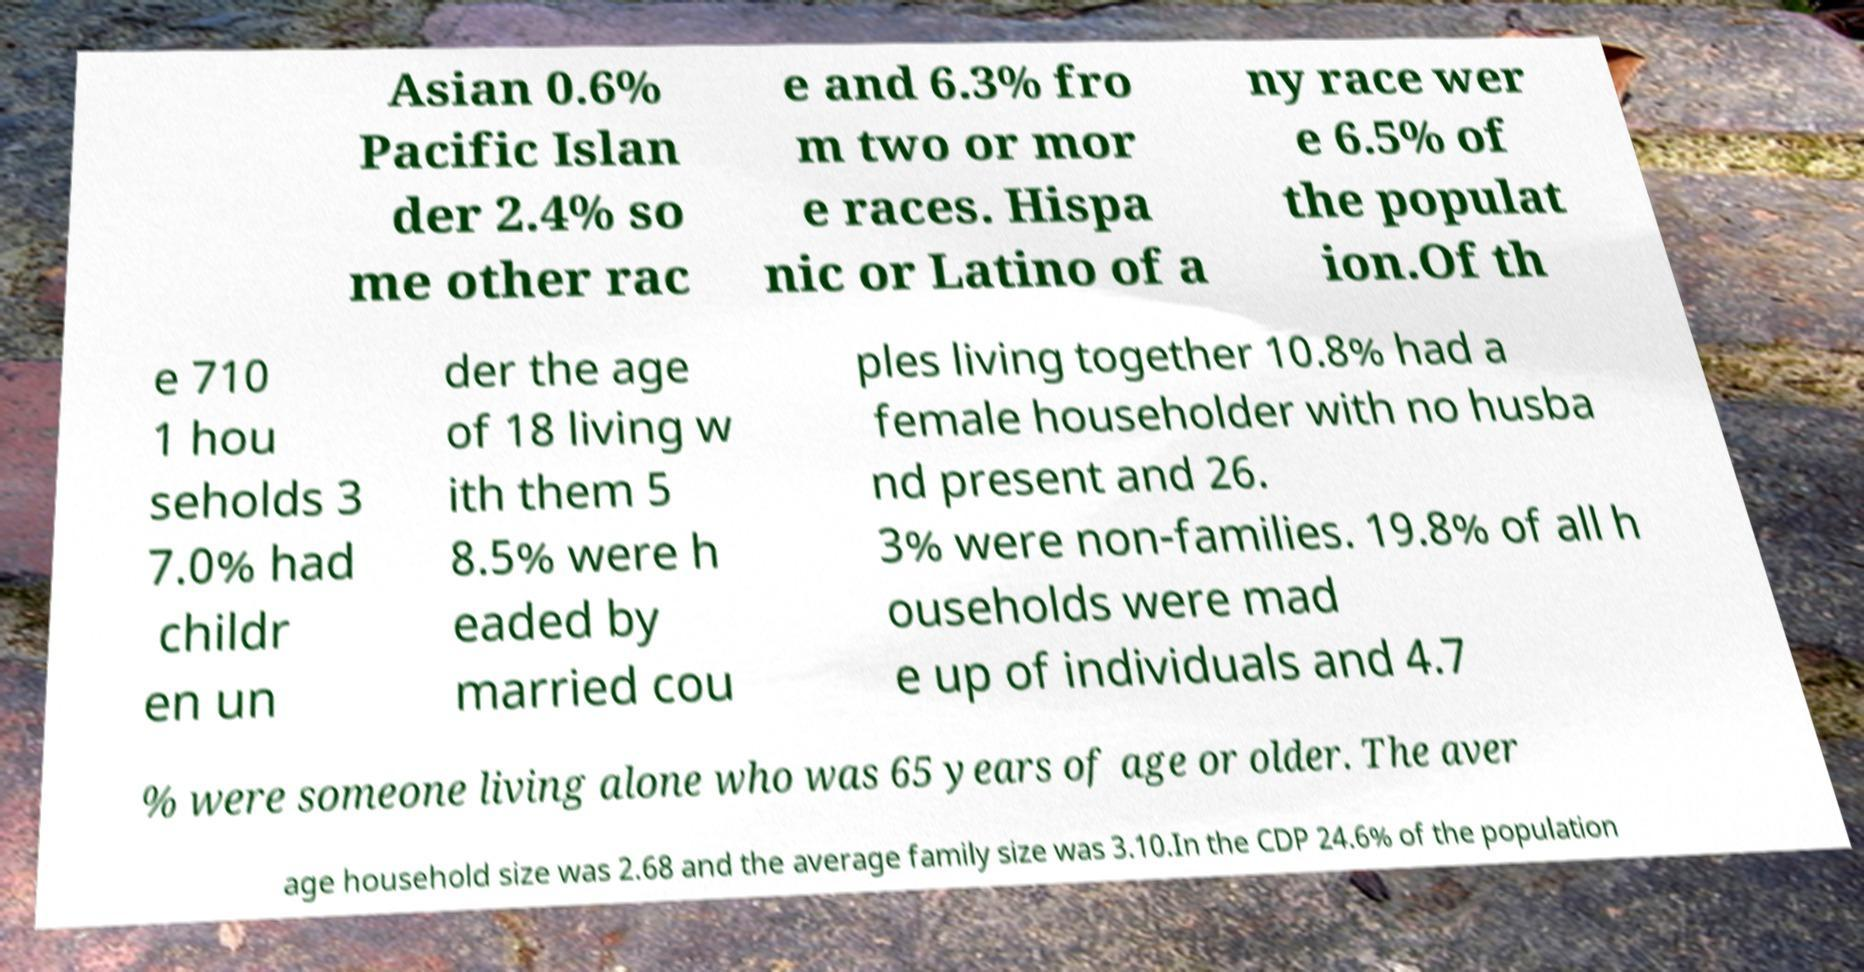Could you extract and type out the text from this image? Asian 0.6% Pacific Islan der 2.4% so me other rac e and 6.3% fro m two or mor e races. Hispa nic or Latino of a ny race wer e 6.5% of the populat ion.Of th e 710 1 hou seholds 3 7.0% had childr en un der the age of 18 living w ith them 5 8.5% were h eaded by married cou ples living together 10.8% had a female householder with no husba nd present and 26. 3% were non-families. 19.8% of all h ouseholds were mad e up of individuals and 4.7 % were someone living alone who was 65 years of age or older. The aver age household size was 2.68 and the average family size was 3.10.In the CDP 24.6% of the population 